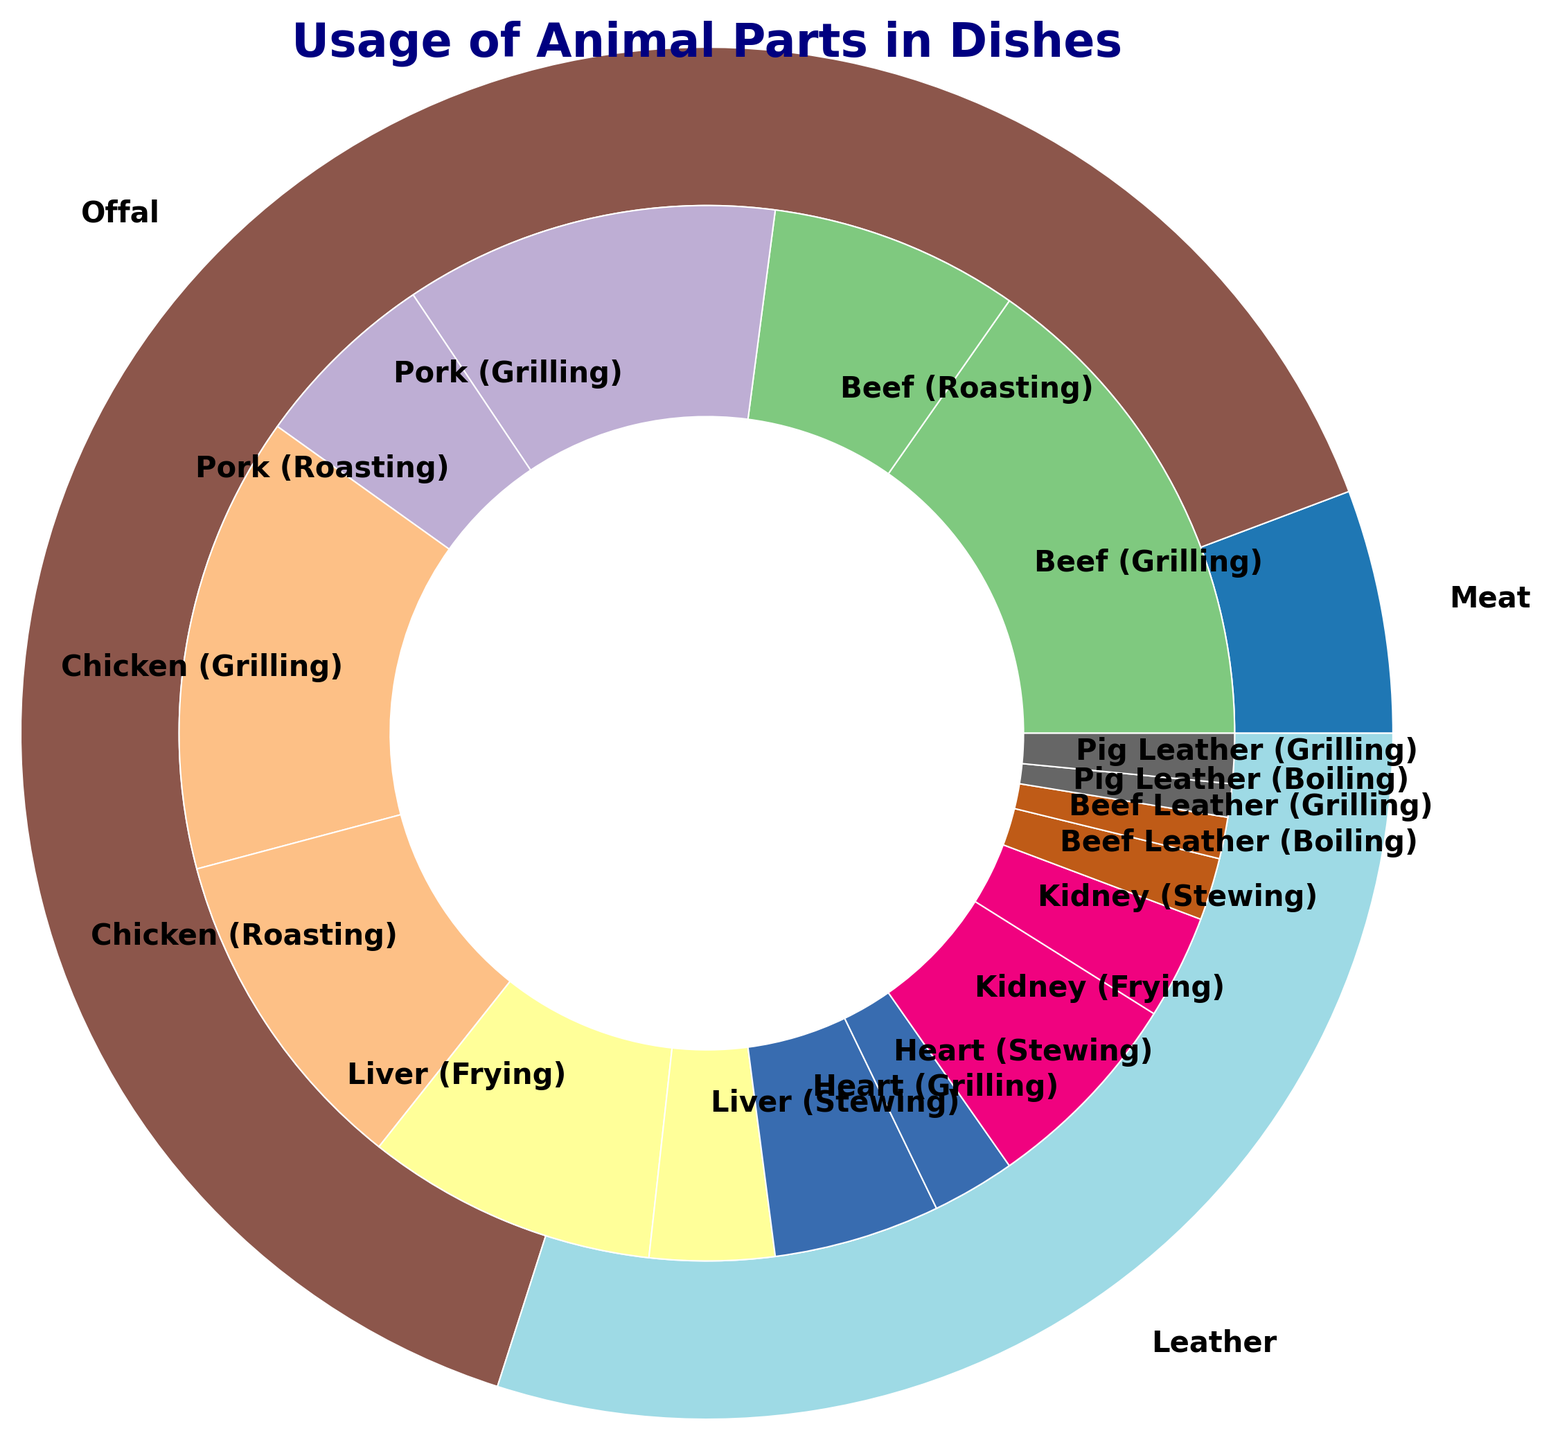Which category has the highest total count of preparations? We need to sum up the counts for each category. Meat has (120+60+90+45+110+80) = 505, Offal has (70+30+40+20+50+25) = 235, Leather has (15+10+8+12) = 45. Meat has the highest total count.
Answer: Meat Among the subcategories in Meat, which preparation method for Beef has the highest count? We need to compare the counts of Beef's preparation methods. Grilling Beef has 120, and Roasting Beef has 60. Grilling has the highest count.
Answer: Grilling Which offal part has the least count in Frying preparation? We look at the Frying preparation within Offal subcategories: Liver (70), Kidney (50). Kidney has the least count.
Answer: Kidney In the Leather category, which subcategory has the more balanced count between its preparation methods? We compare Beef Leather (Boiling 15, Grilling 10) and Pig Leather (Boiling 8, Grilling 12). Pig Leather has the more balanced counts (difference of 4 compared to Beef Leather's difference of 5).
Answer: Pig Leather Which preparation method within the Chicken subcategory has fewer preparations? Comparing Grilling Chicken (110) and Roasting Chicken (80). Roasting has fewer preparations.
Answer: Roasting What is the total count of Roasting preparations across all categories? Sum the counts for Roasting across Meat subcategories: Beef (60), Pork (45), Chicken (80). Total is (60+45+80) = 185.
Answer: 185 Compare the total count of boiling preparations in Leather and Offal categories. Which is higher? Leather Boiling (Beef Leather 15, Pig Leather 8) = 23, Offal has no boiling preparations. Leather has the higher count.
Answer: Leather Is the count of Grilling preparations in Pork greater than the total Grilling preparations in Leather? Pork Grilling count is 90, Leather Grilling (Beef Leather 10, Pig Leather 12) total = 22. Yes, 90 is greater than 22.
Answer: Yes What is the average count of Grilling preparations in the Meat category? Sum the Grilling counts in Meat subcategories: Beef (120), Pork (90), Chicken (110). Total = (120+90+110) = 320. Divide by 3 subcategories. Average = 320/3 = 106.67
Answer: 106.67 Which preparation method has the highest total count across all Leather subcategories? Summing Leather subcategory counts: Boiling (Beef Leather 15, Pig Leather 8, total 23), Grilling (Beef Leather 10, Pig Leather 12, total 22). Boiling has the highest count.
Answer: Boiling 